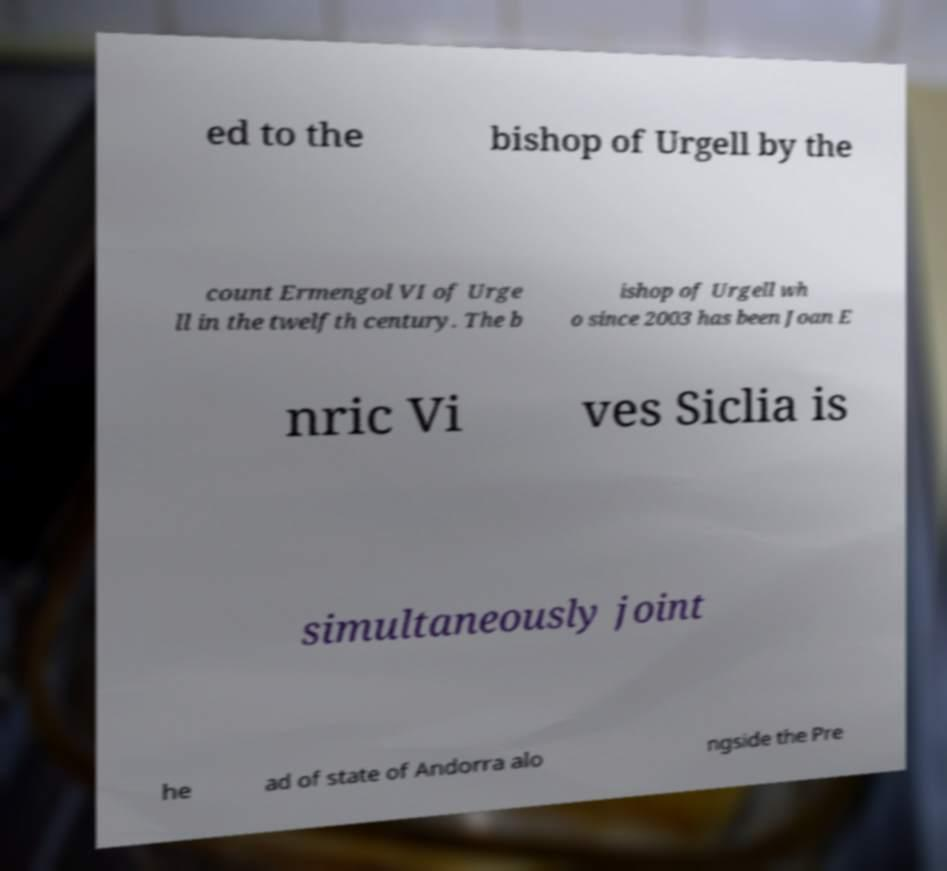Please read and relay the text visible in this image. What does it say? ed to the bishop of Urgell by the count Ermengol VI of Urge ll in the twelfth century. The b ishop of Urgell wh o since 2003 has been Joan E nric Vi ves Siclia is simultaneously joint he ad of state of Andorra alo ngside the Pre 